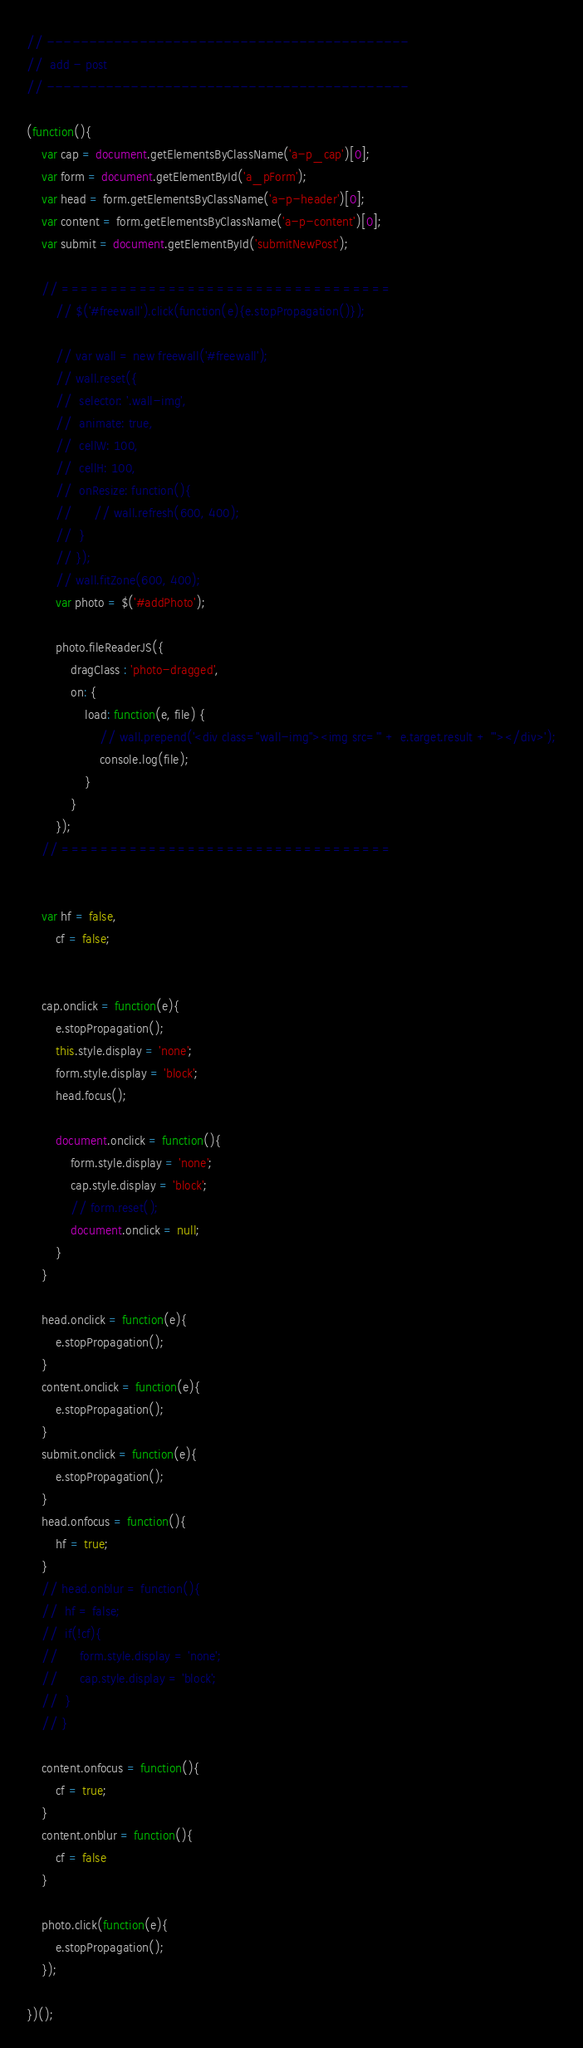Convert code to text. <code><loc_0><loc_0><loc_500><loc_500><_JavaScript_>// -------------------------------------------
//	add - post
// -------------------------------------------

(function(){
	var cap = document.getElementsByClassName('a-p_cap')[0];
	var form = document.getElementById('a_pForm');
	var head = form.getElementsByClassName('a-p-header')[0];
	var content = form.getElementsByClassName('a-p-content')[0];
	var submit = document.getElementById('submitNewPost');

	// ==================================
		// $('#freewall').click(function(e){e.stopPropagation()});

		// var wall = new freewall('#freewall');
		// wall.reset({
		// 	selector: '.wall-img',
		// 	animate: true,
		// 	cellW: 100,
		// 	cellH: 100,
		// 	onResize: function(){
		// 		// wall.refresh(600, 400);
		// 	}
		// });
		// wall.fitZone(600, 400);
		var photo = $('#addPhoto');

		photo.fileReaderJS({
			dragClass : 'photo-dragged',
			on: {
				load: function(e, file) {
					// wall.prepend('<div class="wall-img"><img src="' + e.target.result + '"></div>');
					console.log(file);
				}
			}
		});
	// ==================================


	var hf = false,
		cf = false;


	cap.onclick = function(e){
		e.stopPropagation();
		this.style.display = 'none';
		form.style.display = 'block';
		head.focus();

		document.onclick = function(){
			form.style.display = 'none';
			cap.style.display = 'block';
			// form.reset();
			document.onclick = null;
		}
	}

	head.onclick = function(e){
		e.stopPropagation();
	}
	content.onclick = function(e){
		e.stopPropagation();
	}
	submit.onclick = function(e){
		e.stopPropagation();
	}
	head.onfocus = function(){
		hf = true;
	}
	// head.onblur = function(){
	// 	hf = false;
	// 	if(!cf){
	// 		form.style.display = 'none';
	// 		cap.style.display = 'block';
	// 	}
	// }

	content.onfocus = function(){
		cf = true;
	}
	content.onblur = function(){
		cf = false
	}

	photo.click(function(e){
		e.stopPropagation();
	});

})();</code> 